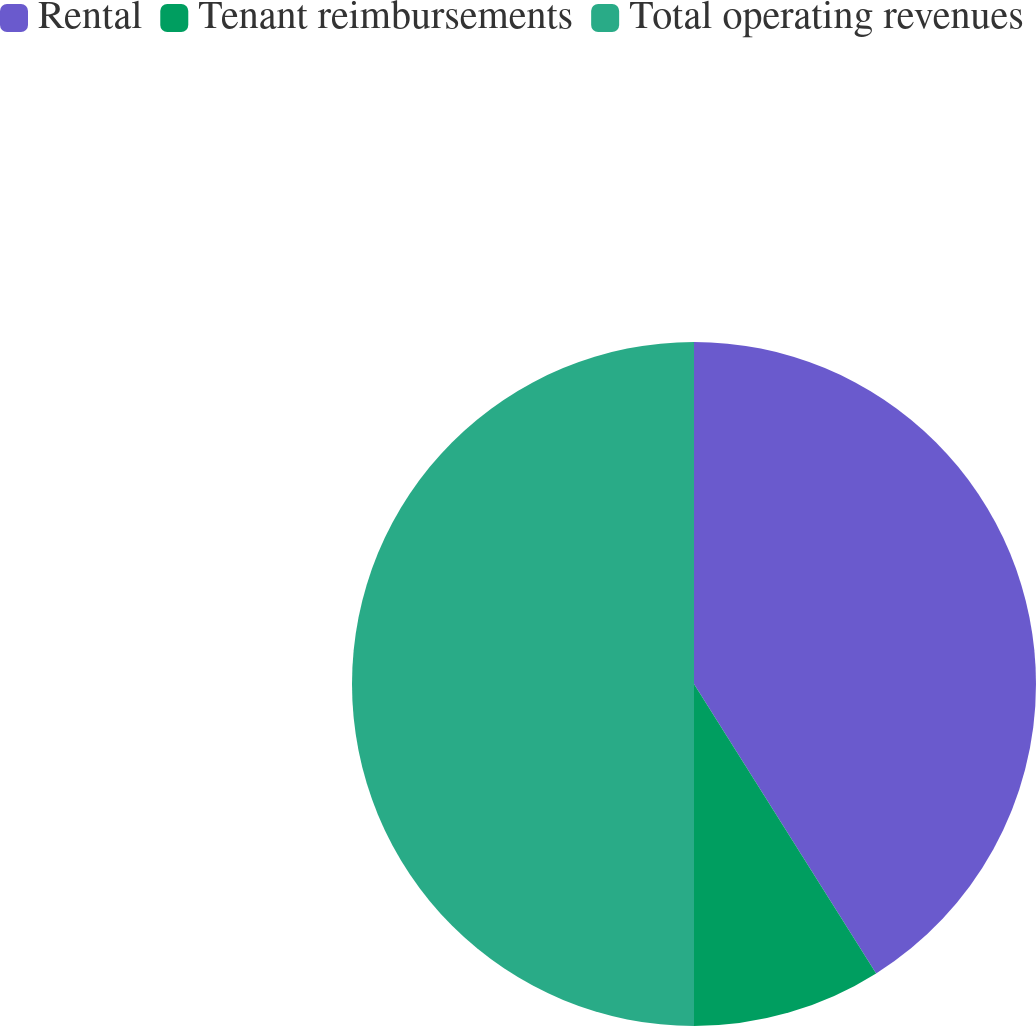Convert chart to OTSL. <chart><loc_0><loc_0><loc_500><loc_500><pie_chart><fcel>Rental<fcel>Tenant reimbursements<fcel>Total operating revenues<nl><fcel>41.06%<fcel>8.94%<fcel>50.0%<nl></chart> 